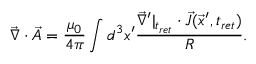<formula> <loc_0><loc_0><loc_500><loc_500>\vec { \nabla } \cdot \vec { A } = \frac { \mu _ { 0 } } { 4 \pi } \int d ^ { 3 } x ^ { \prime } \frac { \vec { \nabla } ^ { \prime } | _ { t _ { r e t } } \cdot \vec { J } ( \vec { x } ^ { \prime } , t _ { r e t } ) } { R } .</formula> 